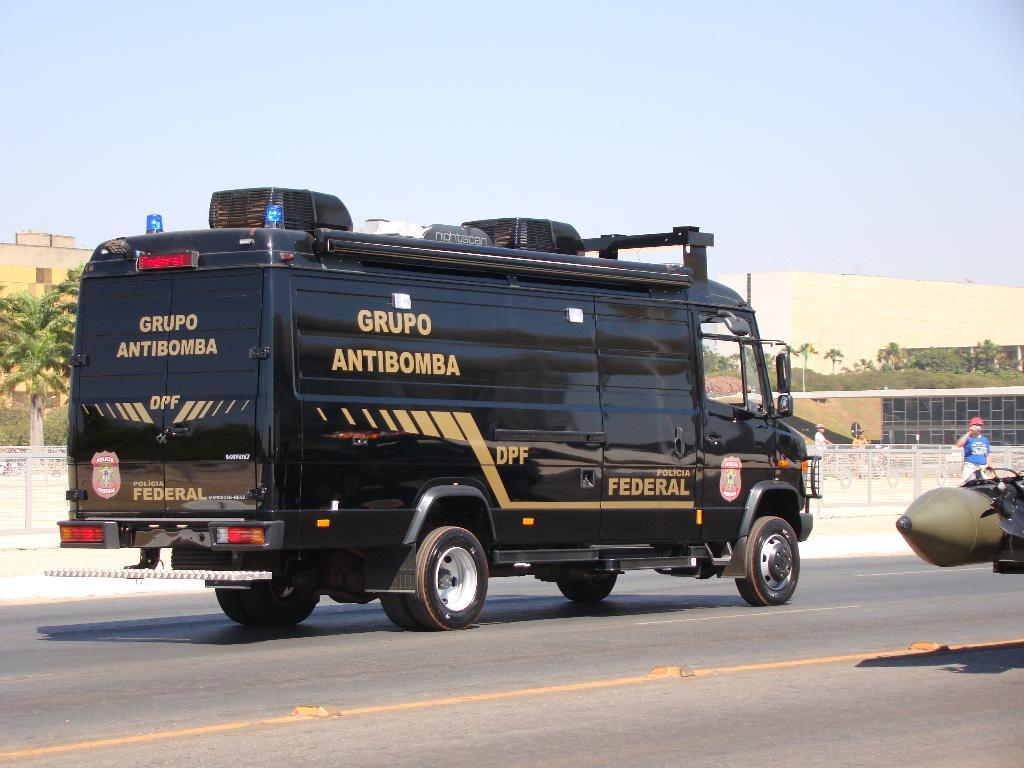<image>
Relay a brief, clear account of the picture shown. A black car from the government is driving down the street. 